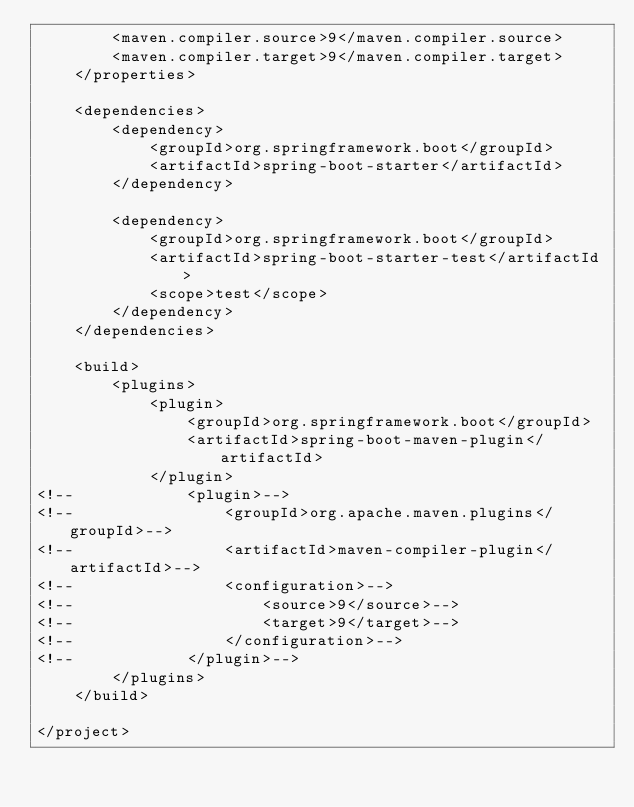<code> <loc_0><loc_0><loc_500><loc_500><_XML_>        <maven.compiler.source>9</maven.compiler.source>
        <maven.compiler.target>9</maven.compiler.target>
    </properties>

    <dependencies>
        <dependency>
            <groupId>org.springframework.boot</groupId>
            <artifactId>spring-boot-starter</artifactId>
        </dependency>

        <dependency>
            <groupId>org.springframework.boot</groupId>
            <artifactId>spring-boot-starter-test</artifactId>
            <scope>test</scope>
        </dependency>
    </dependencies>

    <build>
        <plugins>
            <plugin>
                <groupId>org.springframework.boot</groupId>
                <artifactId>spring-boot-maven-plugin</artifactId>
            </plugin>
<!--            <plugin>-->
<!--                <groupId>org.apache.maven.plugins</groupId>-->
<!--                <artifactId>maven-compiler-plugin</artifactId>-->
<!--                <configuration>-->
<!--                    <source>9</source>-->
<!--                    <target>9</target>-->
<!--                </configuration>-->
<!--            </plugin>-->
        </plugins>
    </build>

</project>
</code> 